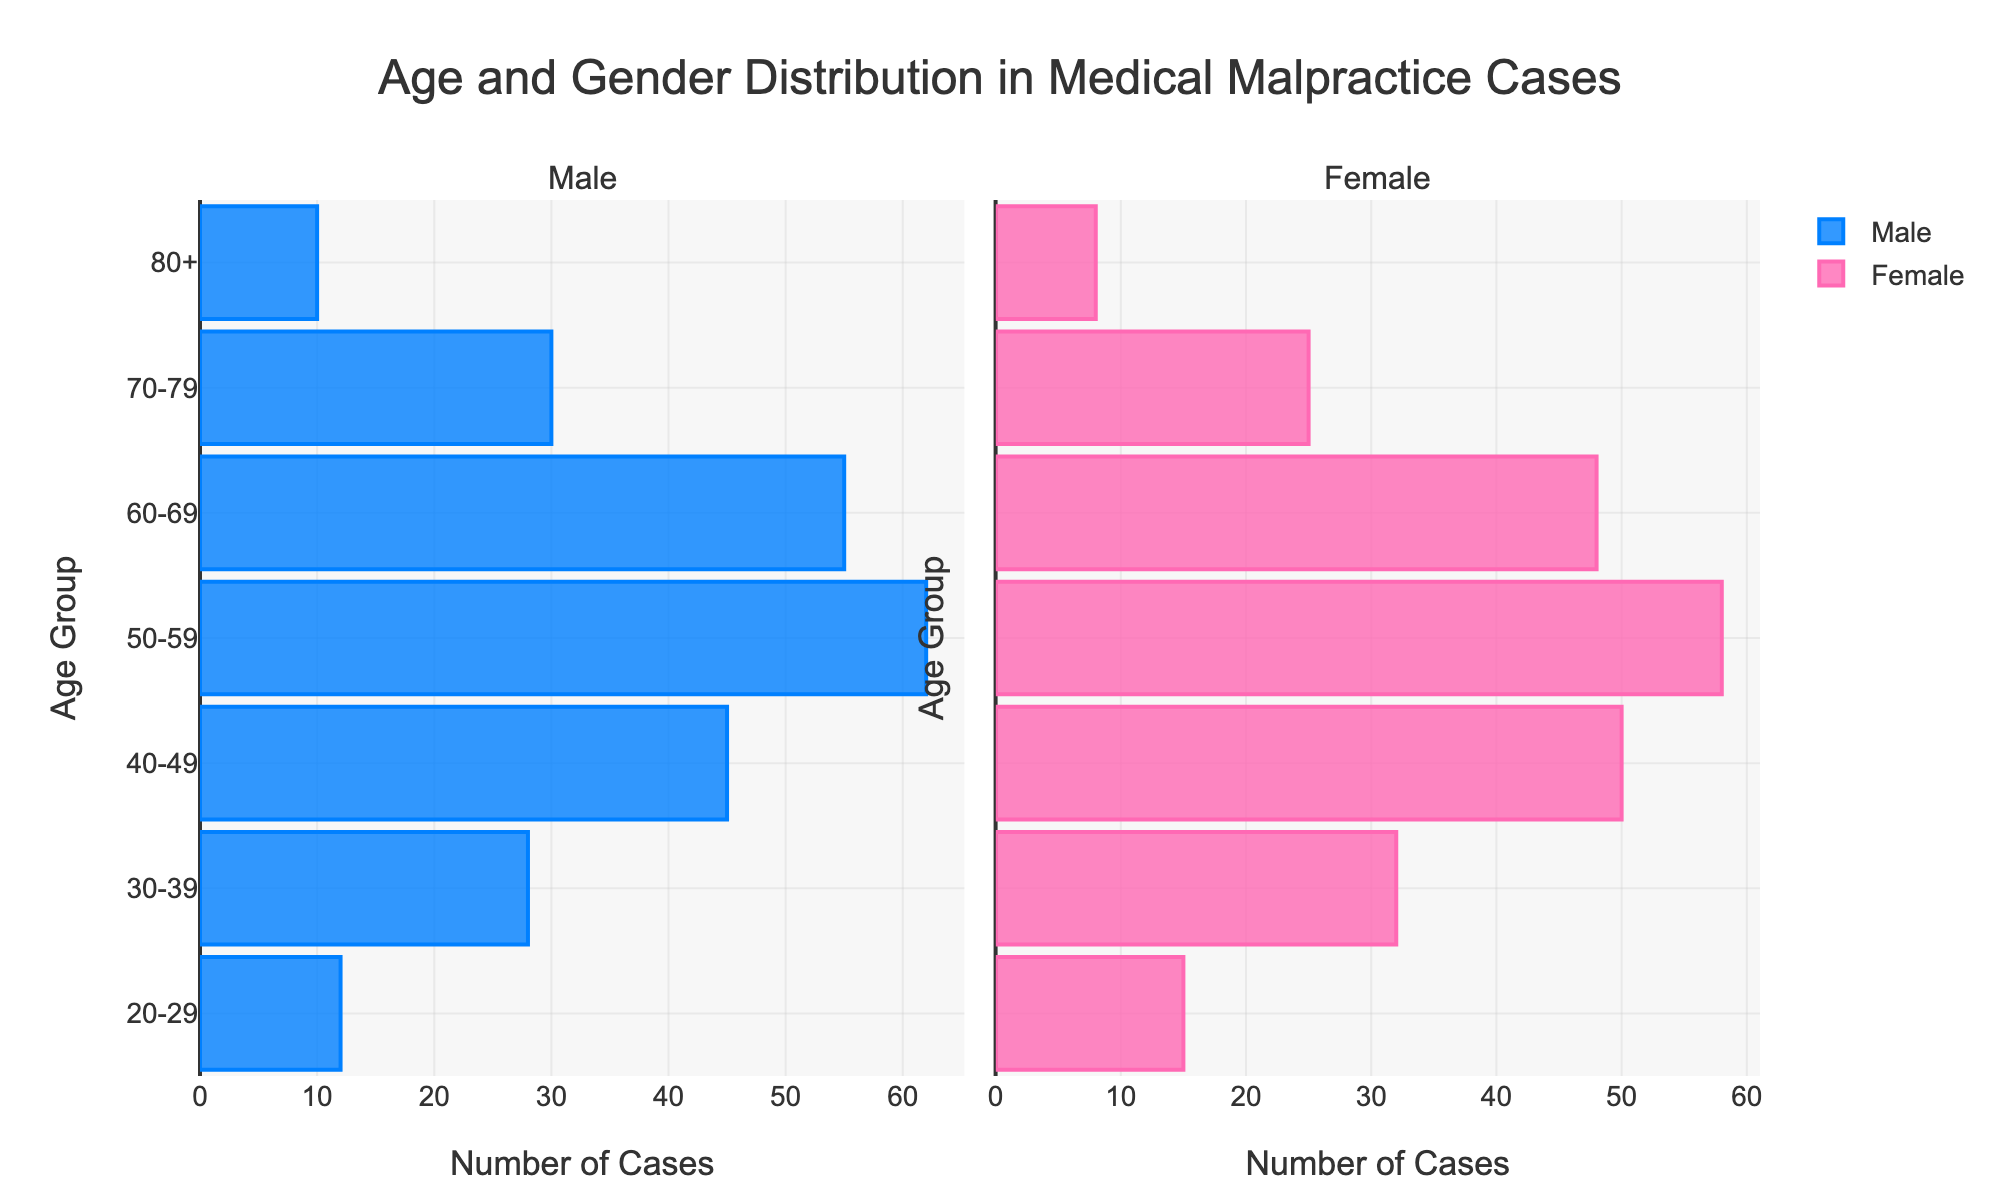How many age groups are presented in the figure? Count the unique age groups listed along the y-axis, which include "20-29", "30-39", "40-49", "50-59", "60-69", "70-79", and "80+"
Answer: 7 What is the title of the figure? The title is displayed prominently at the top center of the figure
Answer: Age and Gender Distribution in Medical Malpractice Cases Which age group has the highest number of male malpractice cases? Look at the longest blue bar on the left side of the figure, which represents the male cases
Answer: 50-59 Which age group has the highest number of female malpractice cases? Look at the longest pink bar on the right side of the figure, which represents the female cases
Answer: 40-49 In the age group 60-69, which gender has more malpractice cases? Compare the lengths of the blue and pink bars for the age group 60-69
Answer: Male What is the total number of female malpractice cases in the age groups 20-29 and 30-39 combined? Add the numbers of cases in the pink bars for the age groups 20-29 (15) and 30-39 (32)
Answer: 47 How does the distribution of male cases change from the age group 40-49 to 50-59? Look at the blue bars for age groups 40-49 and 50-59, and note the difference in length
Answer: Increase Compare the sum of male cases in the age groups 50-59 and 60-69 to the sum of female cases in the same age groups. Which gender has more cases? Sum the values for males (62 + 55 = 117) and females (58 + 48 = 106) in the age groups 50-59 and 60-69, and compare the sums
Answer: Male What is the trend in the number of female malpractice cases as age increases from 20-29 to 80+? Observe the pink bars across ascending age groups and note the trend in case numbers
Answer: Decrease 